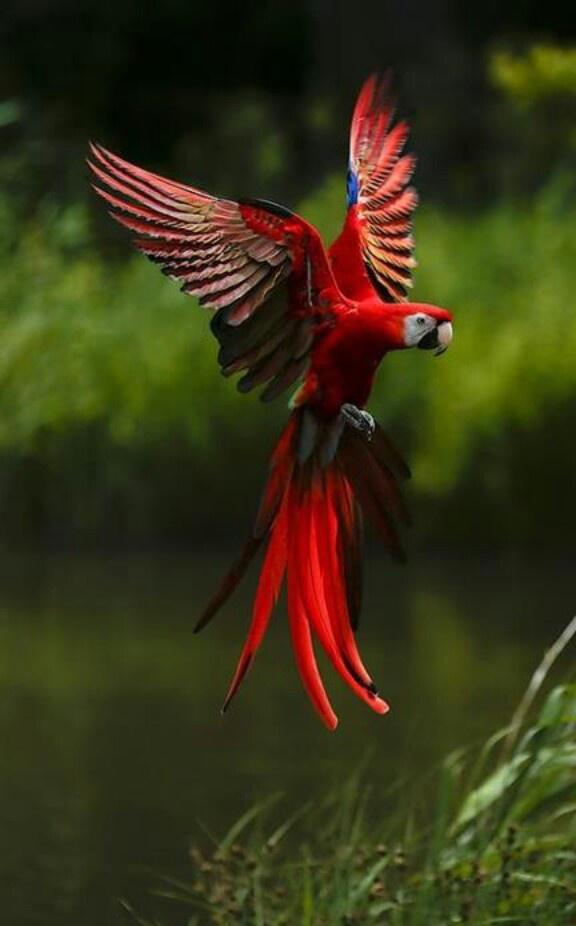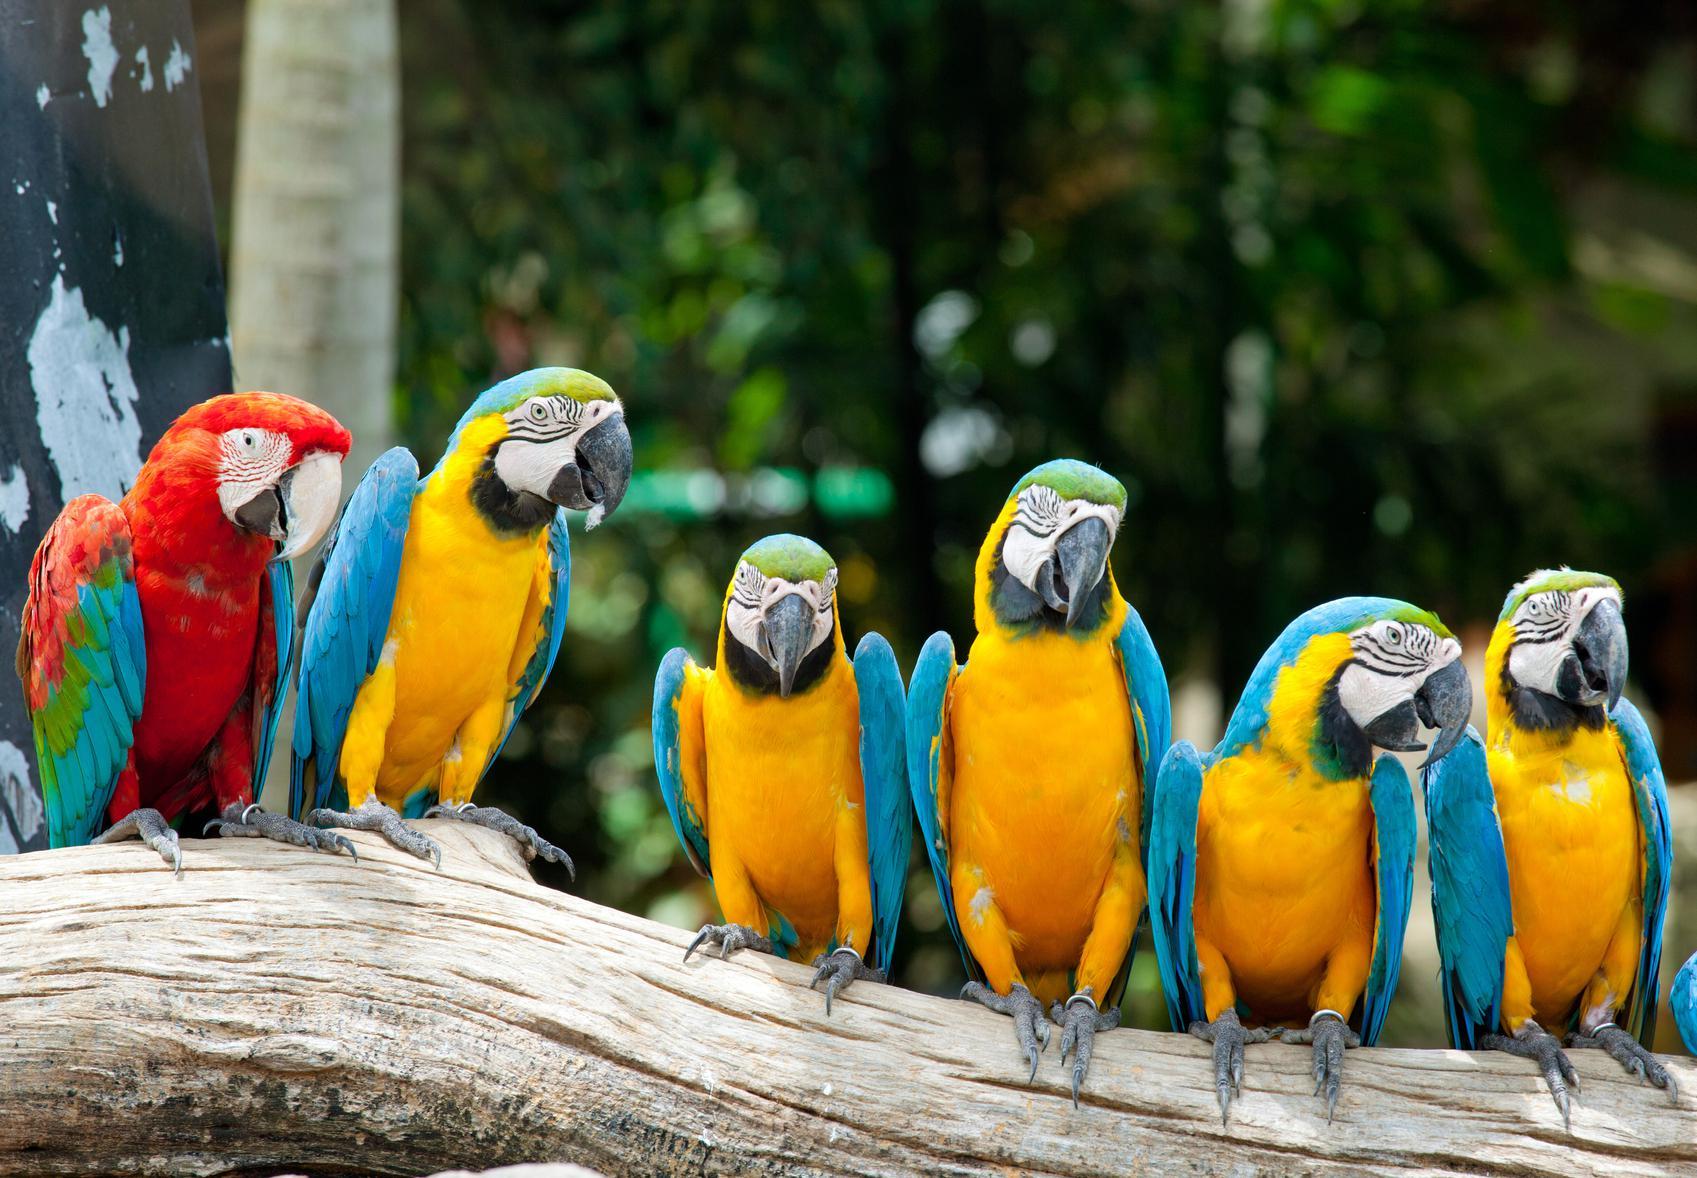The first image is the image on the left, the second image is the image on the right. Assess this claim about the two images: "The left image shows a parrot with wings extended in flight.". Correct or not? Answer yes or no. Yes. 